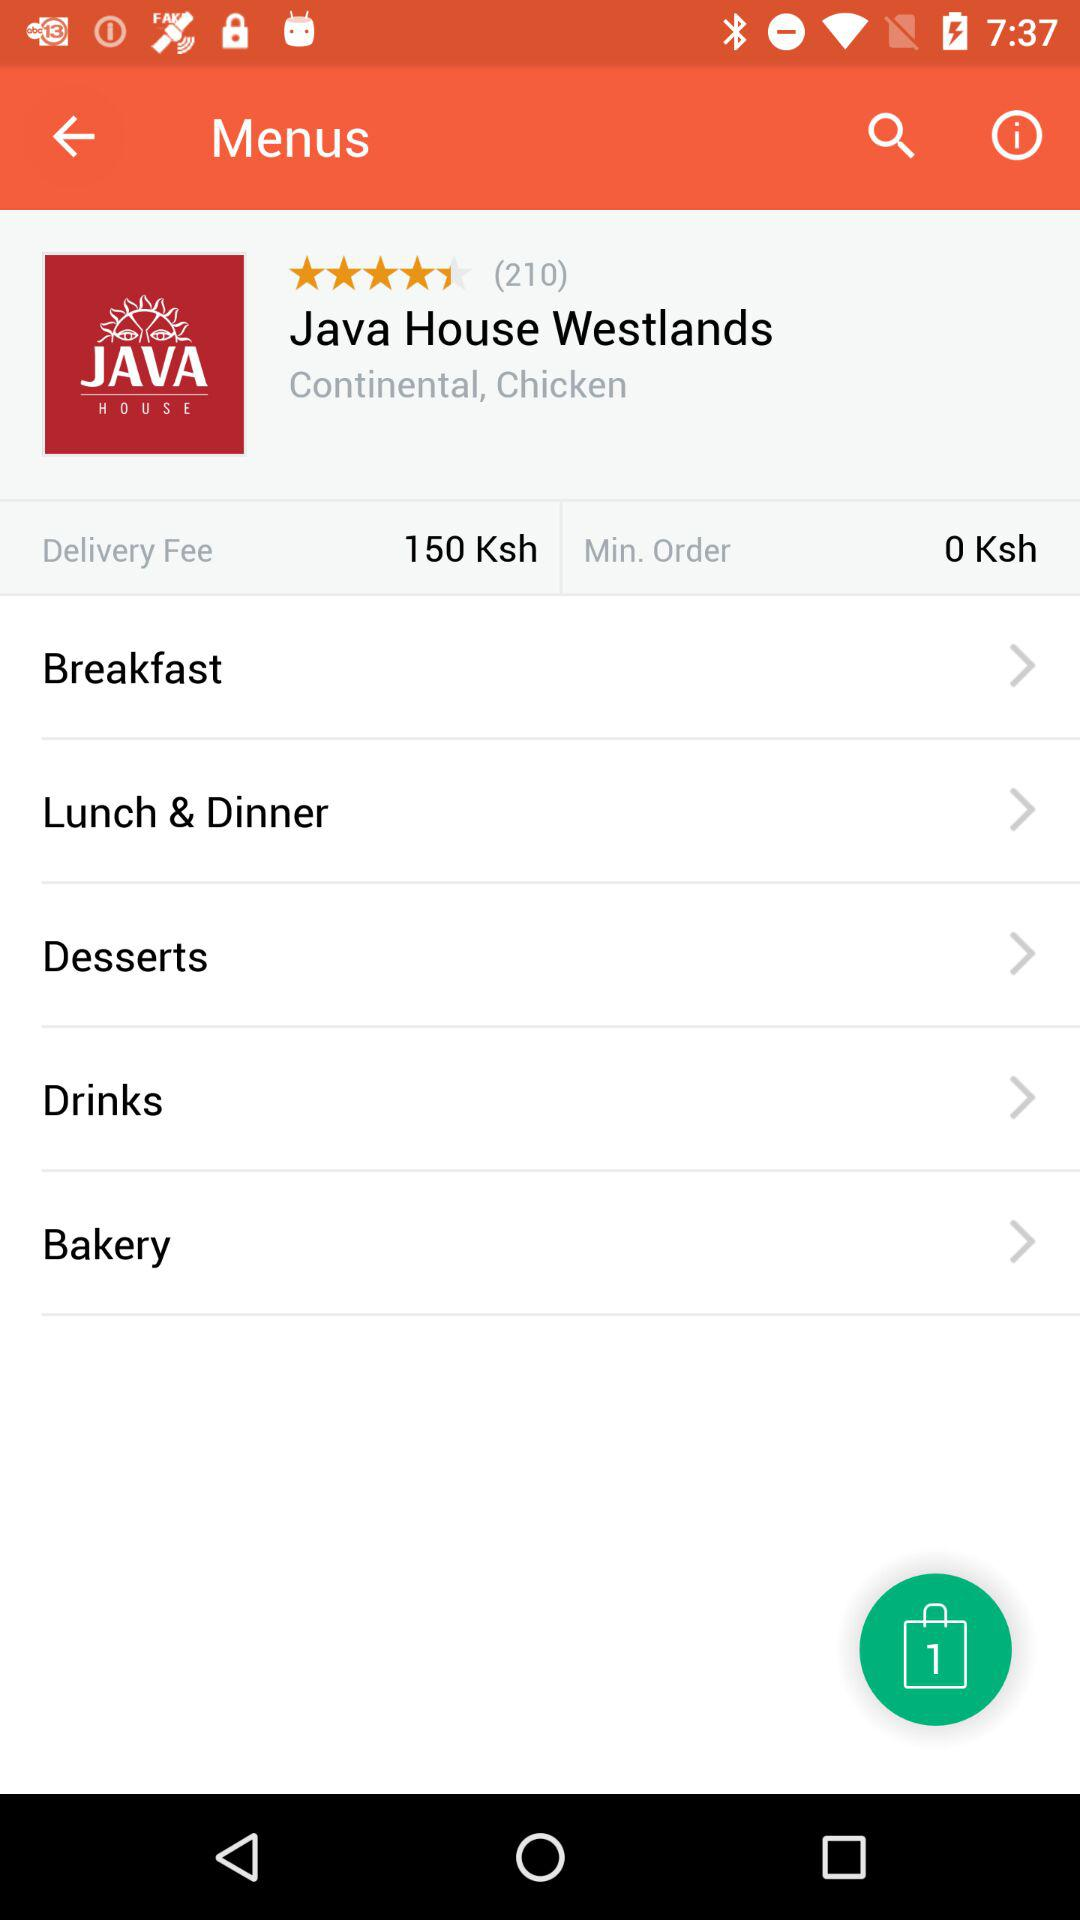How many orders are in the bag? There is 1 order in the bag. 